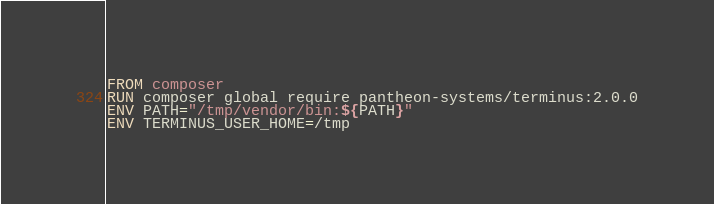<code> <loc_0><loc_0><loc_500><loc_500><_Dockerfile_>FROM composer
RUN composer global require pantheon-systems/terminus:2.0.0
ENV PATH="/tmp/vendor/bin:${PATH}"
ENV TERMINUS_USER_HOME=/tmp
</code> 